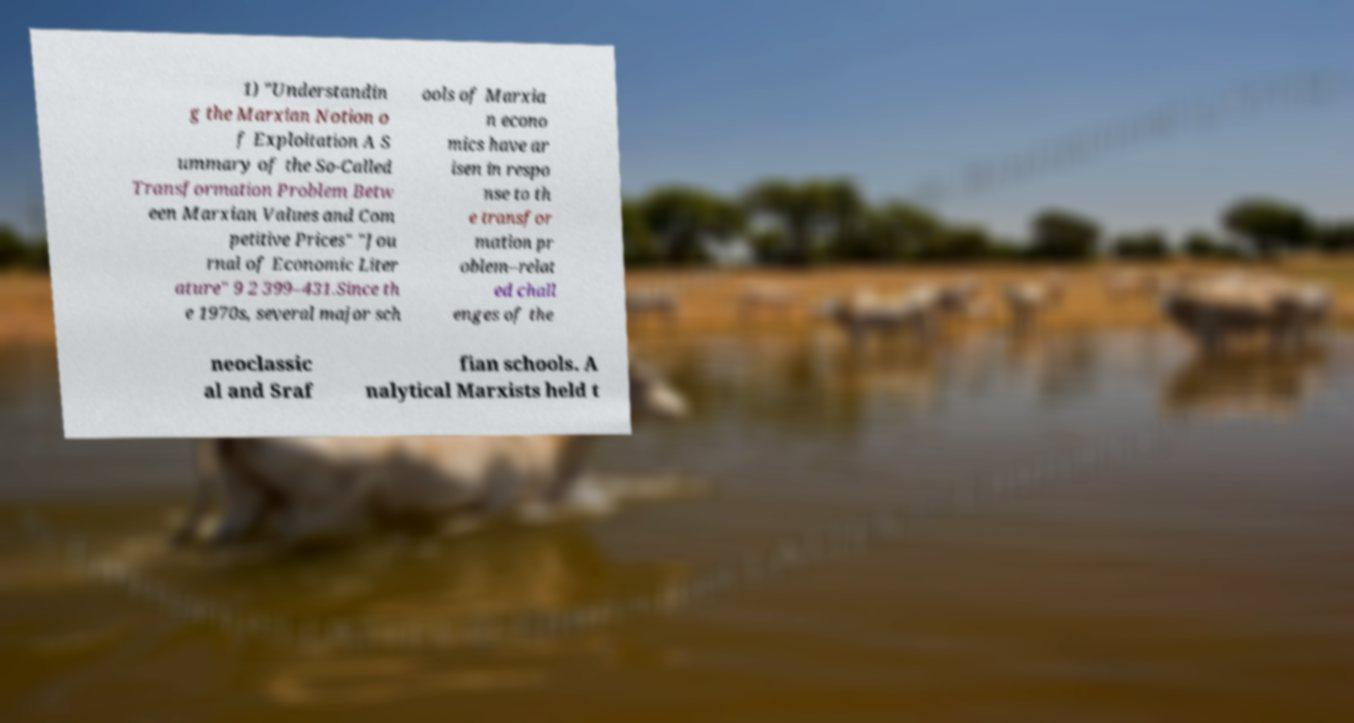Could you assist in decoding the text presented in this image and type it out clearly? 1) "Understandin g the Marxian Notion o f Exploitation A S ummary of the So-Called Transformation Problem Betw een Marxian Values and Com petitive Prices" "Jou rnal of Economic Liter ature" 9 2 399–431.Since th e 1970s, several major sch ools of Marxia n econo mics have ar isen in respo nse to th e transfor mation pr oblem–relat ed chall enges of the neoclassic al and Sraf fian schools. A nalytical Marxists held t 